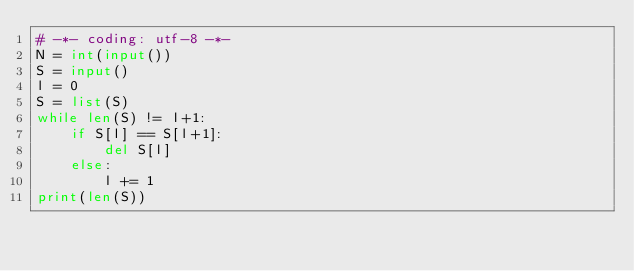<code> <loc_0><loc_0><loc_500><loc_500><_Python_># -*- coding: utf-8 -*-
N = int(input())
S = input()
l = 0
S = list(S)
while len(S) != l+1:
    if S[l] == S[l+1]:
        del S[l]
    else:
        l += 1
print(len(S))</code> 